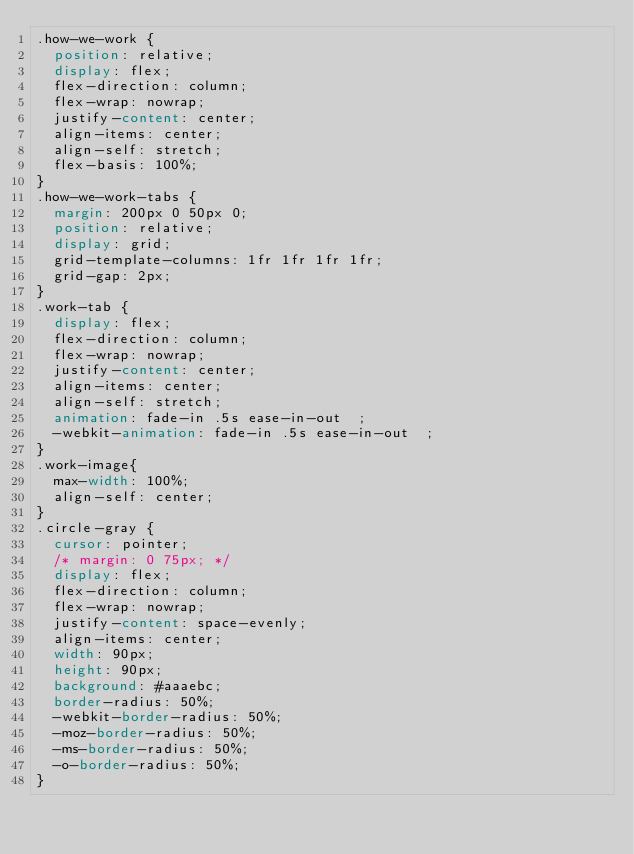Convert code to text. <code><loc_0><loc_0><loc_500><loc_500><_CSS_>.how-we-work {
  position: relative;
  display: flex;
  flex-direction: column;
  flex-wrap: nowrap;
  justify-content: center;
  align-items: center;
  align-self: stretch;
  flex-basis: 100%;
}
.how-we-work-tabs {
  margin: 200px 0 50px 0;
  position: relative;
  display: grid;
  grid-template-columns: 1fr 1fr 1fr 1fr;
  grid-gap: 2px;
}
.work-tab {
  display: flex;
  flex-direction: column;
  flex-wrap: nowrap;
  justify-content: center;
  align-items: center;
  align-self: stretch;
  animation: fade-in .5s ease-in-out  ;
  -webkit-animation: fade-in .5s ease-in-out  ;
}
.work-image{
  max-width: 100%;
  align-self: center;
}
.circle-gray {
  cursor: pointer;
  /* margin: 0 75px; */
  display: flex;
  flex-direction: column;
  flex-wrap: nowrap;
  justify-content: space-evenly;
  align-items: center;
  width: 90px;
  height: 90px;
  background: #aaaebc;
  border-radius: 50%;
  -webkit-border-radius: 50%;
  -moz-border-radius: 50%;
  -ms-border-radius: 50%;
  -o-border-radius: 50%;
}</code> 